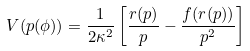<formula> <loc_0><loc_0><loc_500><loc_500>V ( p ( \phi ) ) = \frac { 1 } { 2 \kappa ^ { 2 } } \left [ \frac { r ( p ) } { p } - \frac { f ( r ( p ) ) } { p ^ { 2 } } \right ]</formula> 